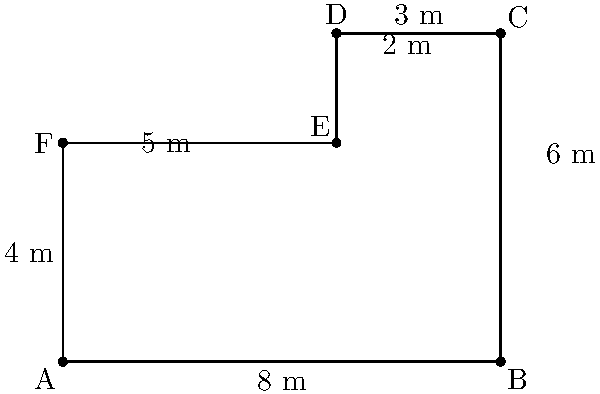A local brick-and-mortar store has a layout as shown in the diagram. The store manager wants to calculate the total floor area to determine the optimal arrangement of product displays. Using coordinate geometry, calculate the total floor area of the store in square meters. To calculate the total floor area, we need to break down the store layout into two rectangles and use the area formula for rectangles.

Step 1: Identify the two rectangles
- Rectangle 1: ABEF (main area)
- Rectangle 2: DCDE (additional area)

Step 2: Calculate the area of Rectangle 1 (ABEF)
- Width = 8 m (from A to B)
- Height = 4 m (from A to F)
- Area of Rectangle 1 = $8 \times 4 = 32$ sq m

Step 3: Calculate the area of Rectangle 2 (DCDE)
- Width = 3 m (from D to C)
- Height = 2 m (from E to D)
- Area of Rectangle 2 = $3 \times 2 = 6$ sq m

Step 4: Calculate the total floor area
Total floor area = Area of Rectangle 1 + Area of Rectangle 2
Total floor area = $32 + 6 = 38$ sq m

Therefore, the total floor area of the store is 38 square meters.
Answer: 38 sq m 